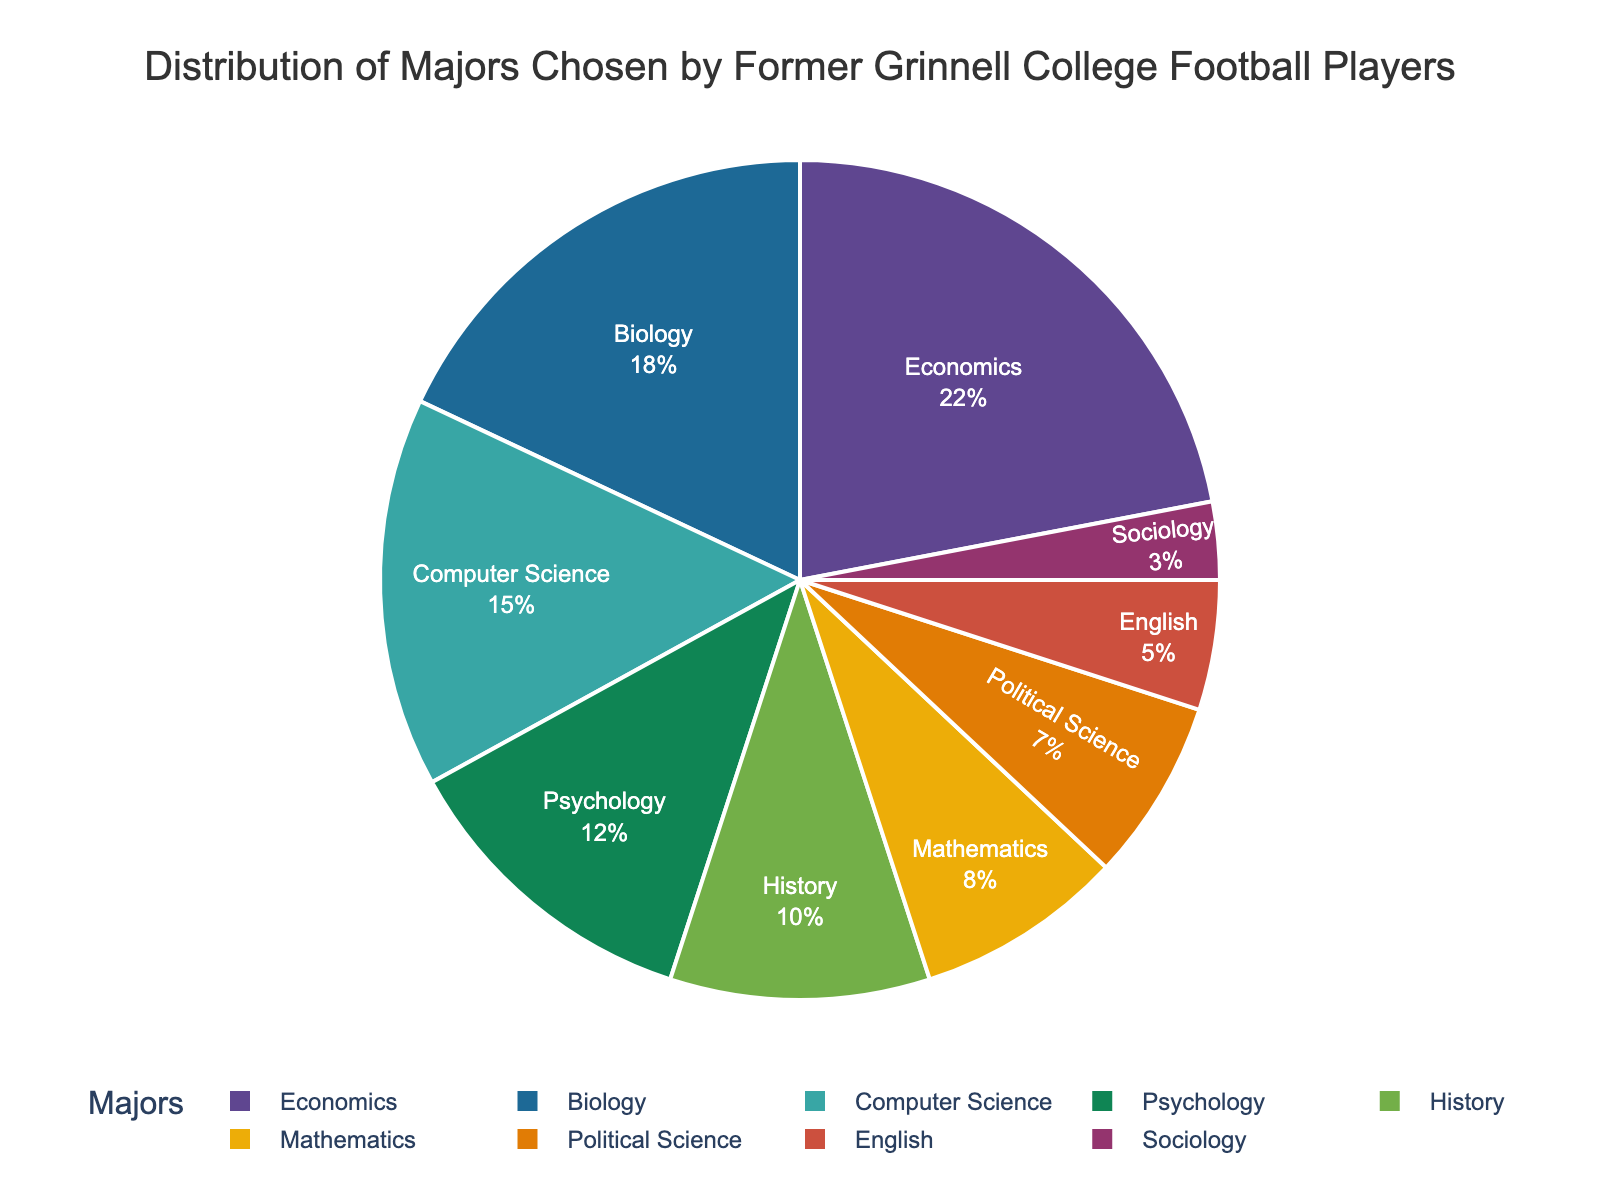what percentage of former Grinnell College football players majored in Psychology and History combined? To find the combined percentage, add the individual percentages of Psychology and History. Psychology is 12% and History is 10%, thus the combined total is 12 + 10 = 22%.
Answer: 22% Which major has the lowest percentage of former Grinnell College football players? By looking at the pie chart, the smallest segment corresponds to Sociology, which has 3%.
Answer: Sociology Is the proportion of Biology majors greater than Mathematics and Political Science combined? To compare, add the percentages of Mathematics and Political Science. Mathematics is 8% and Political Science is 7%, so their combined percentage is 8 + 7 = 15%. Biology has 18%, which is greater than 15%.
Answer: Yes How many majors have a percentage of 10% or more? Look at all the segments and count those with 10% or more. They are Economics (22%), Biology (18%), Computer Science (15%), Psychology (12%), and History (10%). Thus, there are 5 majors.
Answer: 5 Among the majors with less than 10%, which one has the highest percentage? For majors with less than 10%, look at Sociology (3%), English (5%), Mathematics (8%), and Political Science (7%). Mathematics has the highest among these, at 8%.
Answer: Mathematics How does the percentage of Economics majors compare to that of Bio majors? Economics holds 22% while Biology holds 18%. Comparing these, Economics has the higher percentage.
Answer: Economics What is the total percentage of majors in STEM (Science, Technology, Engineering, and Math)? STEM majors include Biology (18%), Computer Science (15%), and Mathematics (8%). Summing these gives 18 + 15 + 8 = 41%.
Answer: 41% Compare the percentages of English and Sociology majors and determine the difference between them. English is 5% and Sociology is 3%. The difference is 5 - 3 = 2%.
Answer: 2% Which major has the median percentage among the given majors? Arrange the percentages in ascending order: 3, 5, 7, 8, 10, 12, 15, 18, 22. The median is the middle value, which is History at 10%.
Answer: History 